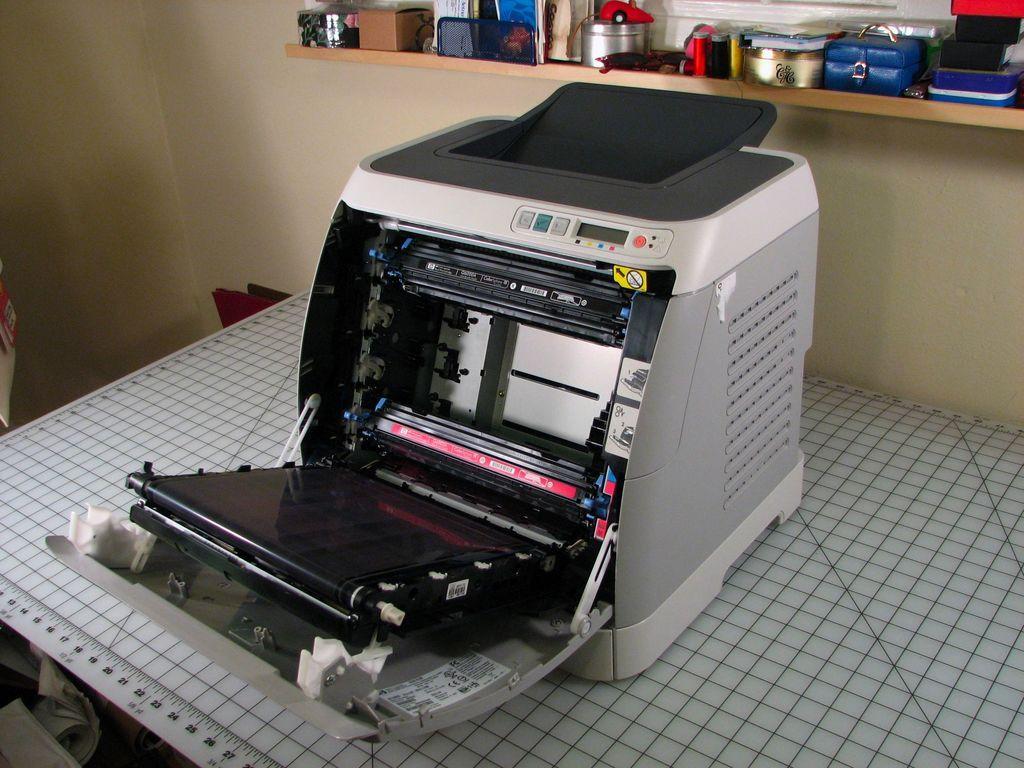In one or two sentences, can you explain what this image depicts? In the picture I can see a machine on a table. In the background I can see a shelf attached to the wall. On the shelf I can see some objects. 